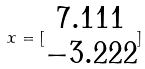Convert formula to latex. <formula><loc_0><loc_0><loc_500><loc_500>x = [ \begin{matrix} 7 . 1 1 1 \\ - 3 . 2 2 2 \end{matrix} ]</formula> 